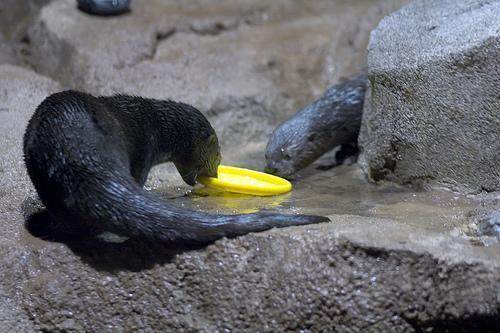How many otters are in this picture?
Give a very brief answer. 2. How many people are in this picture?
Give a very brief answer. 0. 